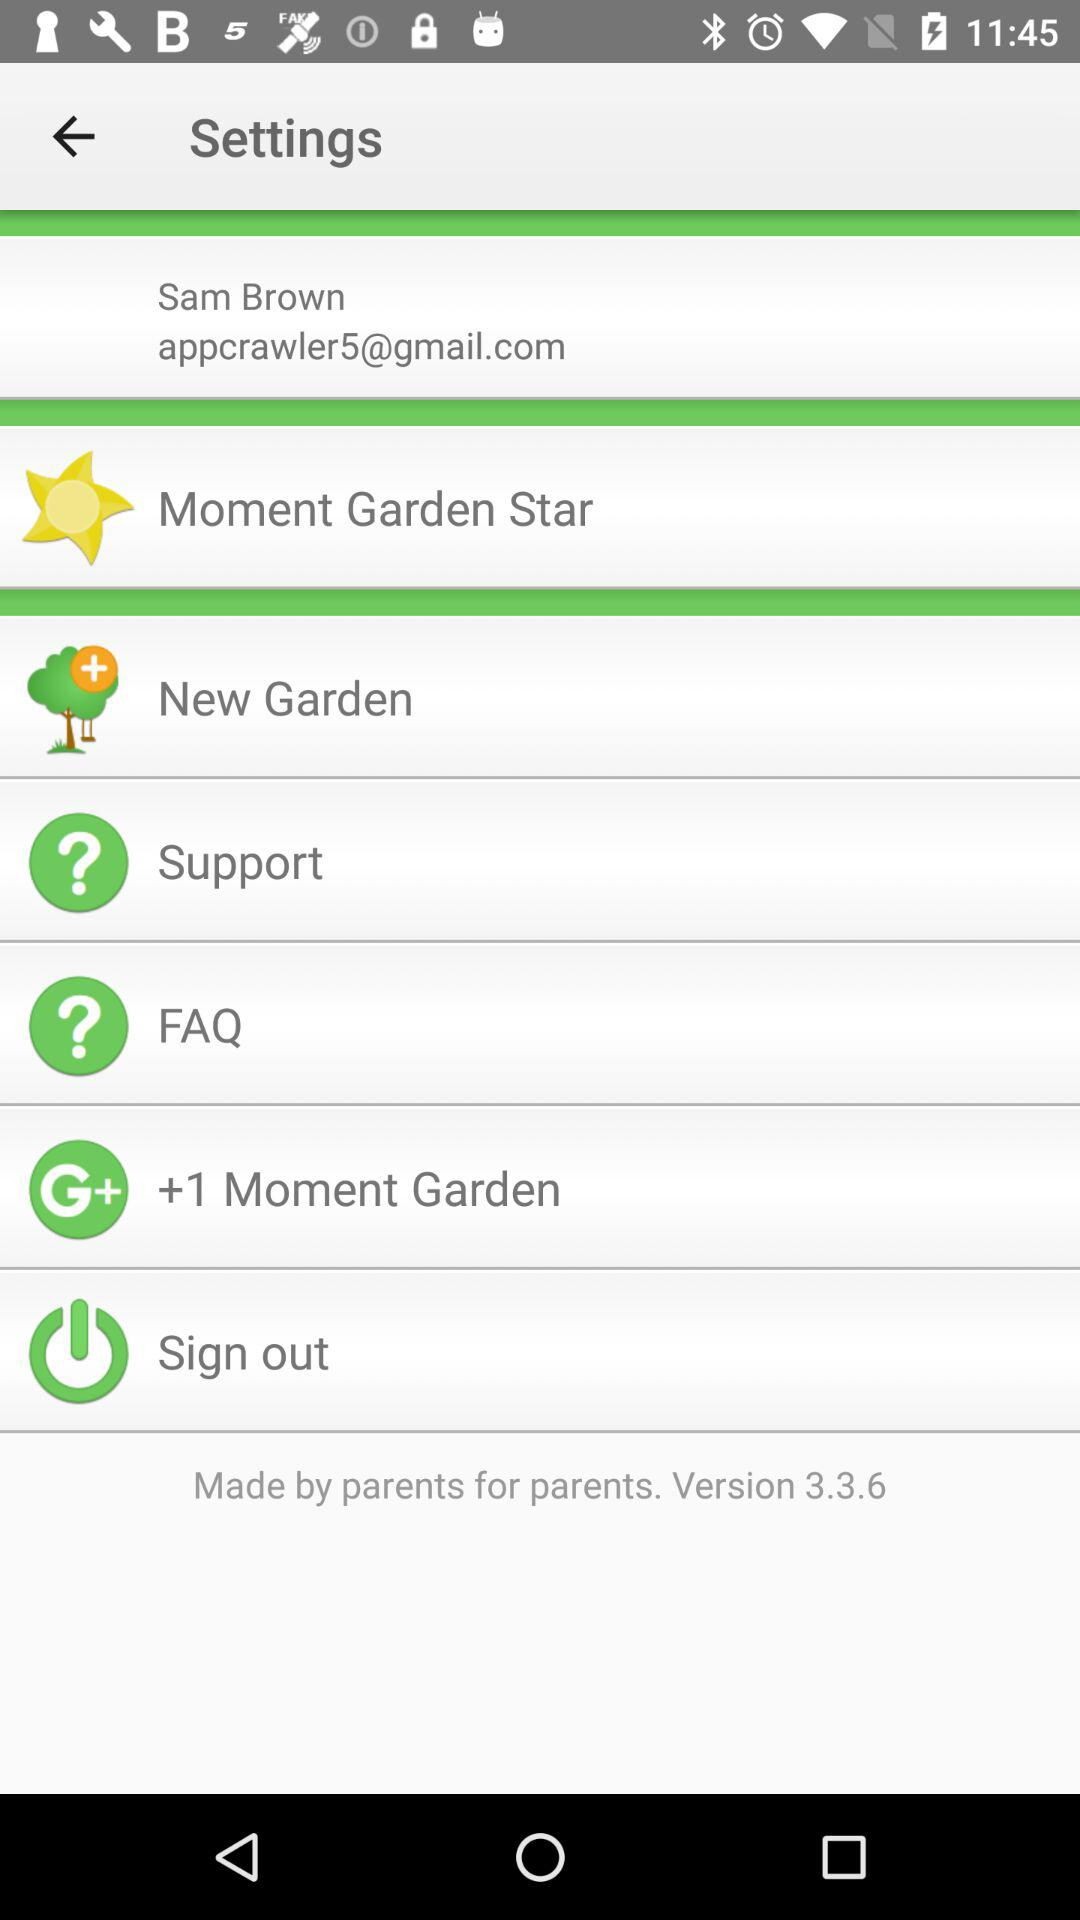What is the user name? The user name is Sam Brown. 